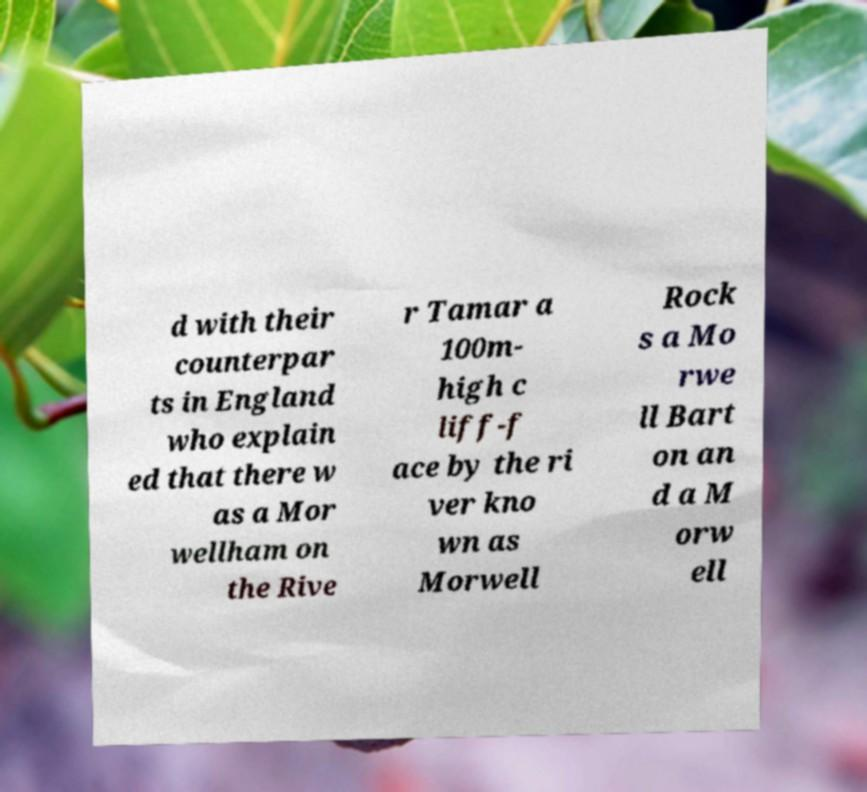What messages or text are displayed in this image? I need them in a readable, typed format. d with their counterpar ts in England who explain ed that there w as a Mor wellham on the Rive r Tamar a 100m- high c liff-f ace by the ri ver kno wn as Morwell Rock s a Mo rwe ll Bart on an d a M orw ell 